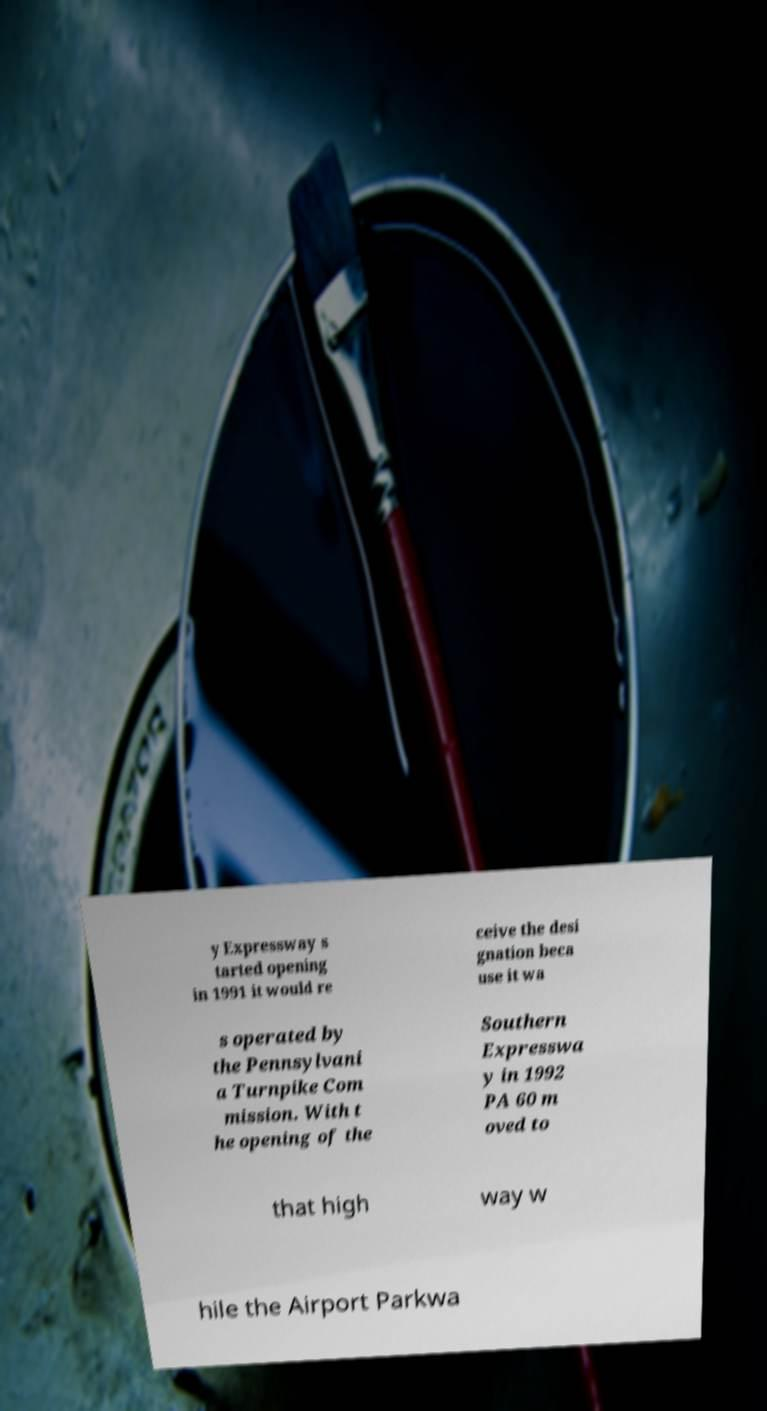Can you accurately transcribe the text from the provided image for me? y Expressway s tarted opening in 1991 it would re ceive the desi gnation beca use it wa s operated by the Pennsylvani a Turnpike Com mission. With t he opening of the Southern Expresswa y in 1992 PA 60 m oved to that high way w hile the Airport Parkwa 